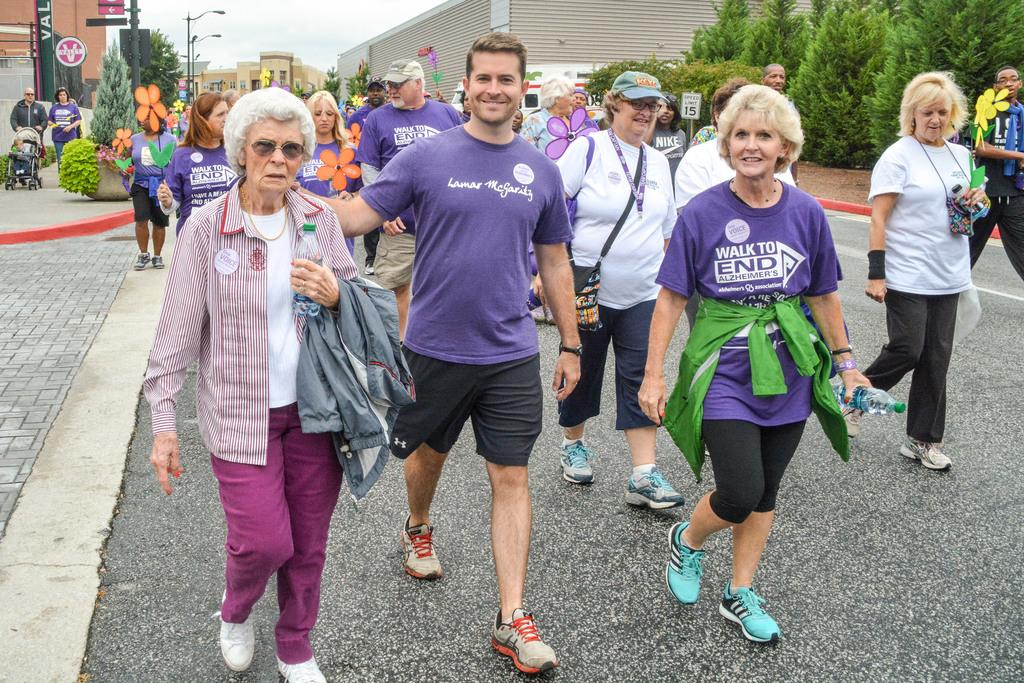How many people are in the image? There is a group of people in the image. What are the people in the image doing? The people are walking. What can be seen in the background of the image? There are trees, buildings, and street lamps in the background of the image. What expert advice can be seen in the image? There is no expert advice present in the image; it features a group of people walking with a background of trees, buildings, and street lamps. 